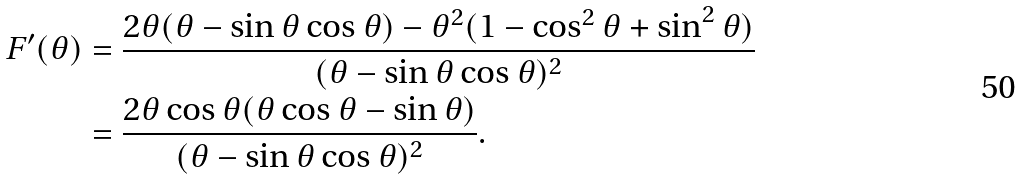Convert formula to latex. <formula><loc_0><loc_0><loc_500><loc_500>F ^ { \prime } ( \theta ) & = \frac { 2 \theta ( \theta - \sin \theta \cos \theta ) - \theta ^ { 2 } ( 1 - \cos ^ { 2 } \theta + \sin ^ { 2 } \theta ) } { ( \theta - \sin \theta \cos \theta ) ^ { 2 } } \\ & = \frac { 2 \theta \cos \theta ( \theta \cos \theta - \sin \theta ) } { ( \theta - \sin \theta \cos \theta ) ^ { 2 } } .</formula> 